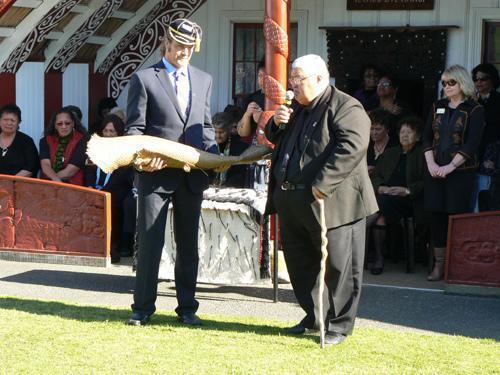What is the thin object the man holding the microphone is using to prop up called?
Choose the right answer and clarify with the format: 'Answer: answer
Rationale: rationale.'
Options: Cane, dagger, shovel, flute. Answer: cane.
Rationale: The object is the length of the height of the man's waist to the ground.   it is about the width of five fingers.  it is sturdy and can hold a lot of weight without breaking. 